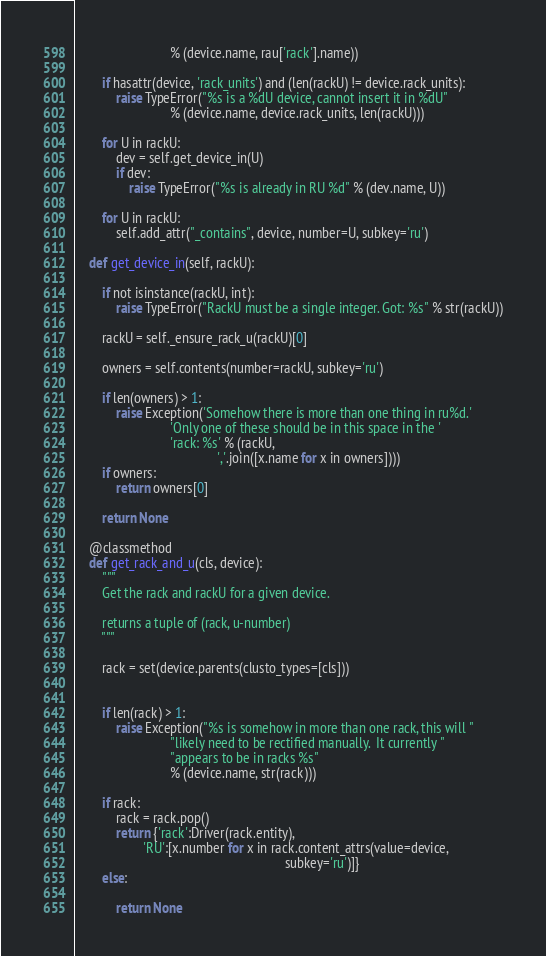<code> <loc_0><loc_0><loc_500><loc_500><_Python_>                            % (device.name, rau['rack'].name))

        if hasattr(device, 'rack_units') and (len(rackU) != device.rack_units):
            raise TypeError("%s is a %dU device, cannot insert it in %dU"
                            % (device.name, device.rack_units, len(rackU)))

        for U in rackU:
            dev = self.get_device_in(U)
            if dev:
                raise TypeError("%s is already in RU %d" % (dev.name, U))

        for U in rackU:
            self.add_attr("_contains", device, number=U, subkey='ru')

    def get_device_in(self, rackU):

        if not isinstance(rackU, int):
            raise TypeError("RackU must be a single integer. Got: %s" % str(rackU))

        rackU = self._ensure_rack_u(rackU)[0]

        owners = self.contents(number=rackU, subkey='ru')

        if len(owners) > 1:
            raise Exception('Somehow there is more than one thing in ru%d.'
                            'Only one of these should be in this space in the '
                            'rack: %s' % (rackU,
                                          ','.join([x.name for x in owners])))
        if owners:
            return owners[0]

        return None

    @classmethod
    def get_rack_and_u(cls, device):
        """
        Get the rack and rackU for a given device.

        returns a tuple of (rack, u-number)
        """

        rack = set(device.parents(clusto_types=[cls]))


        if len(rack) > 1:
            raise Exception("%s is somehow in more than one rack, this will "
                            "likely need to be rectified manually.  It currently "
                            "appears to be in racks %s"
                            % (device.name, str(rack)))

        if rack:
            rack = rack.pop()
            return {'rack':Driver(rack.entity),
                    'RU':[x.number for x in rack.content_attrs(value=device,
                                                              subkey='ru')]}
        else:

            return None
</code> 